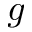Convert formula to latex. <formula><loc_0><loc_0><loc_500><loc_500>g</formula> 